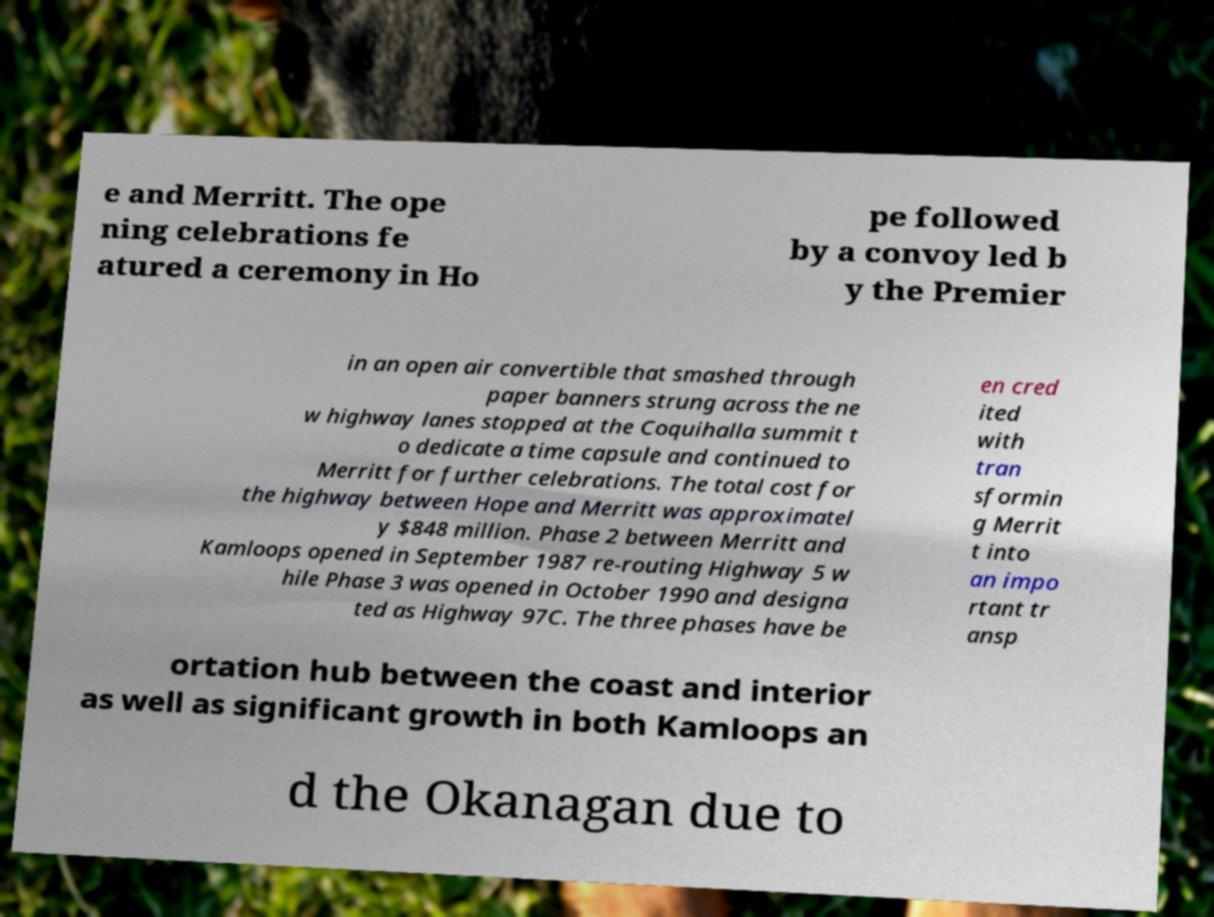Could you extract and type out the text from this image? e and Merritt. The ope ning celebrations fe atured a ceremony in Ho pe followed by a convoy led b y the Premier in an open air convertible that smashed through paper banners strung across the ne w highway lanes stopped at the Coquihalla summit t o dedicate a time capsule and continued to Merritt for further celebrations. The total cost for the highway between Hope and Merritt was approximatel y $848 million. Phase 2 between Merritt and Kamloops opened in September 1987 re-routing Highway 5 w hile Phase 3 was opened in October 1990 and designa ted as Highway 97C. The three phases have be en cred ited with tran sformin g Merrit t into an impo rtant tr ansp ortation hub between the coast and interior as well as significant growth in both Kamloops an d the Okanagan due to 